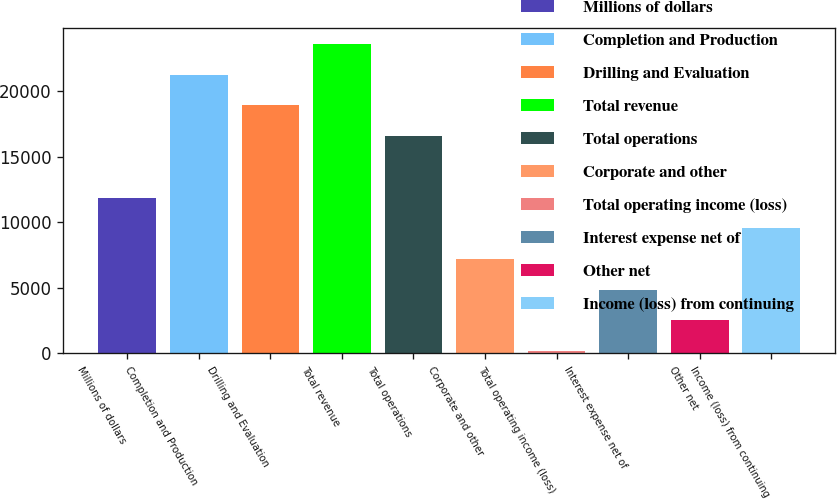Convert chart. <chart><loc_0><loc_0><loc_500><loc_500><bar_chart><fcel>Millions of dollars<fcel>Completion and Production<fcel>Drilling and Evaluation<fcel>Total revenue<fcel>Total operations<fcel>Corporate and other<fcel>Total operating income (loss)<fcel>Interest expense net of<fcel>Other net<fcel>Income (loss) from continuing<nl><fcel>11899<fcel>21286.2<fcel>18939.4<fcel>23633<fcel>16592.6<fcel>7205.4<fcel>165<fcel>4858.6<fcel>2511.8<fcel>9552.2<nl></chart> 